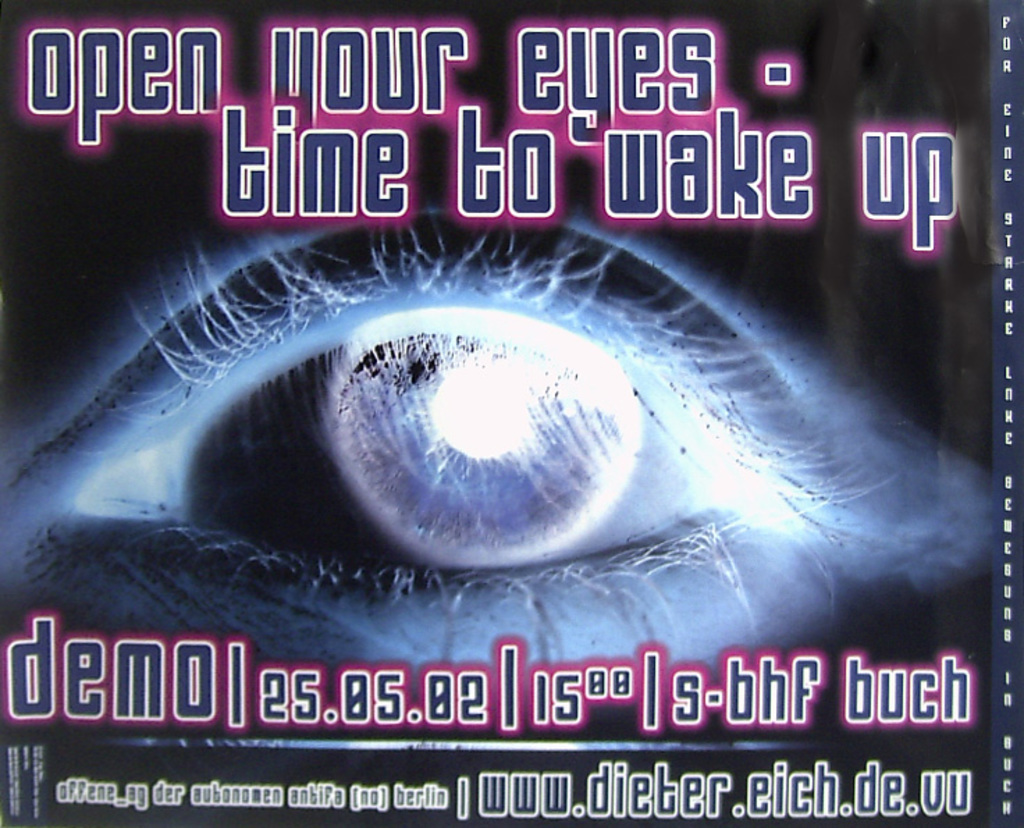What do you think is going on in this snapshot? The image is a dynamic promotional poster for a potentially philosophical or self-awareness themed German book titled 'demo es.as.be lsa-bhf buch' by Dieter Eich. The focal point is a piercing eye surrounded by a nebulous, dark background, and neon text reading 'open your eyes - time to wake up.' This suggests that the book might explore themes of perception, reality, and maybe a call to action for societal or personal change. With an atmospheric and somewhat eerie visual style, this poster aims to provoke curiosity and alertness among viewers, in line with what could be a transformative narrative of the book. 